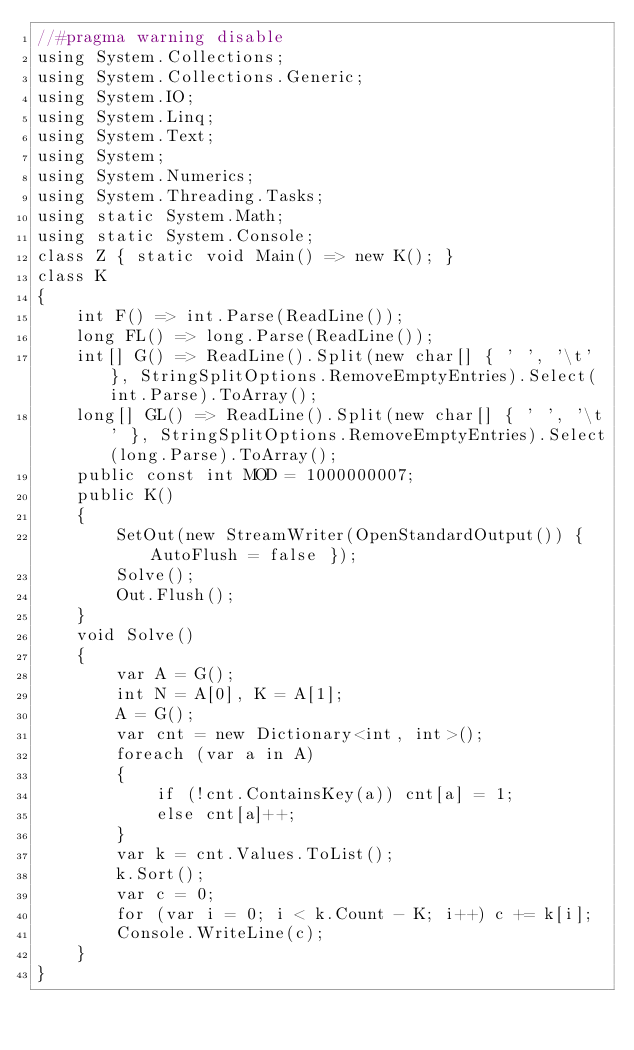<code> <loc_0><loc_0><loc_500><loc_500><_C#_>//#pragma warning disable
using System.Collections;
using System.Collections.Generic;
using System.IO;
using System.Linq;
using System.Text;
using System;
using System.Numerics;
using System.Threading.Tasks;
using static System.Math;
using static System.Console;
class Z { static void Main() => new K(); }
class K
{
	int F() => int.Parse(ReadLine());
	long FL() => long.Parse(ReadLine());
	int[] G() => ReadLine().Split(new char[] { ' ', '\t' }, StringSplitOptions.RemoveEmptyEntries).Select(int.Parse).ToArray();
	long[] GL() => ReadLine().Split(new char[] { ' ', '\t' }, StringSplitOptions.RemoveEmptyEntries).Select(long.Parse).ToArray();
	public const int MOD = 1000000007;
	public K()
	{
		SetOut(new StreamWriter(OpenStandardOutput()) { AutoFlush = false });
		Solve();
		Out.Flush();
	}
	void Solve()
	{
		var A = G();
		int N = A[0], K = A[1];
		A = G();
		var cnt = new Dictionary<int, int>();
		foreach (var a in A)
		{
			if (!cnt.ContainsKey(a)) cnt[a] = 1;
			else cnt[a]++;
		}
		var k = cnt.Values.ToList();
		k.Sort();
		var c = 0;
		for (var i = 0; i < k.Count - K; i++) c += k[i];
		Console.WriteLine(c);
	}
}
</code> 